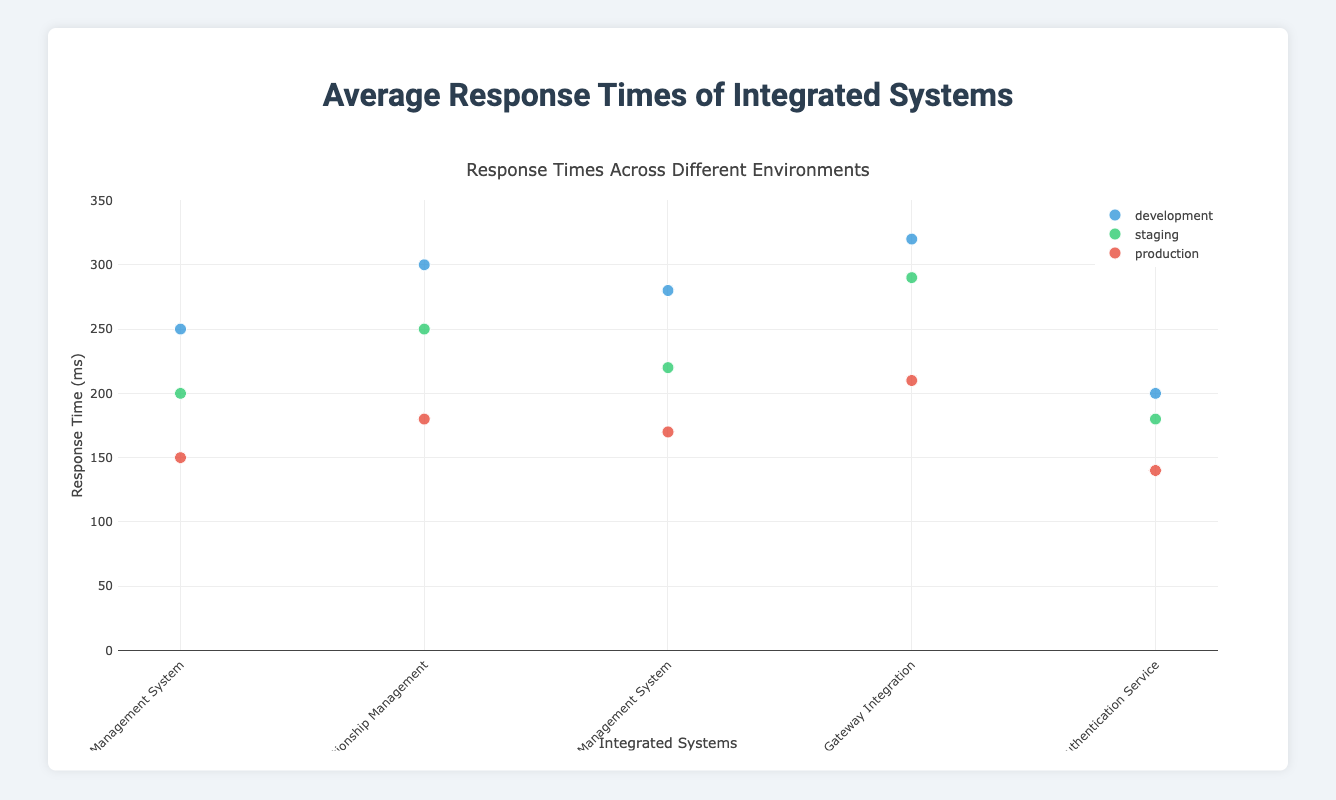What is the title of the plot? The title is usually placed at the top and describes the main content of the plot. Here, the title "Average Response Times of Integrated Systems" is clearly displayed.
Answer: Average Response Times of Integrated Systems Which environment has the lowest average response time for the "Payment Gateway Integration" system? By looking at the plot, you can find the "Payment Gateway Integration" system and check the response time for each environment. For production, it is 210ms, which is the lowest.
Answer: production What is the color used to represent the "staging" environment? The colors for each environment are listed in the code: development (blue), staging (green), production (red). Therefore, green is for the staging environment.
Answer: green Which integrated system has the highest response time in the development environment? In the plot, observe the response times for all systems in the development environment. The "Payment Gateway Integration" system has the highest response time of 320ms.
Answer: Payment Gateway Integration Compare the response times of the "Order Management System" across all environments. Which environment shows the largest difference in response time compared to development? Check the response times for the "Order Management System": development (250ms), staging (200ms), and production (150ms). The largest difference is 250ms - 150ms = 100ms, which is for the production environment.
Answer: production What is the average response time for the "Customer Relationship Management" system across all environments? Add the response times together: 300ms (development) + 250ms (staging) + 180ms (production) = 730ms. The average is 730ms / 3 environments = 243.33ms.
Answer: 243.33ms Which integrated system has the smallest response time in the production environment? Look at the plot and identify the smallest response time for the production environment. The "User Authentication Service" has the smallest response time of 140ms.
Answer: User Authentication Service How many integrated systems' response times are displayed in the plot? Each unique system name indicates an integrated system. List out the unique system names: Order Management System, Customer Relationship Management, Inventory Management System, Payment Gateway Integration, and User Authentication Service. There are 5 systems.
Answer: 5 Between "Inventory Management System" and "User Authentication Service", which has a higher average response time across all environments? Calculate the average for both systems:
- Inventory Management System: (280ms + 220ms + 170ms) / 3 = 223.33ms 
- User Authentication Service: (200ms + 180ms + 140ms) / 3 = 173.33ms 
Therefore, the "Inventory Management System" has a higher average response time.
Answer: Inventory Management System Which environment generally shows the lowest response times across all integrated systems? Check the response times for each environment across all systems. Production generally shows the lowest response times compared to development and staging environments across all systems in the plot.
Answer: production 